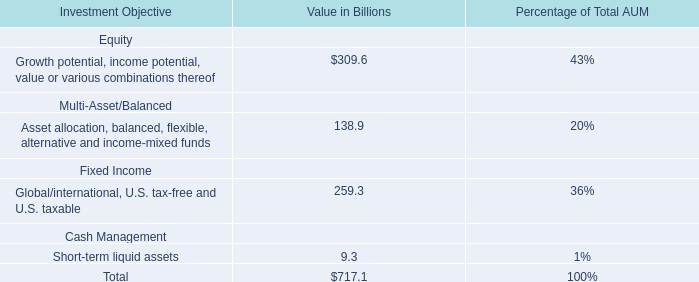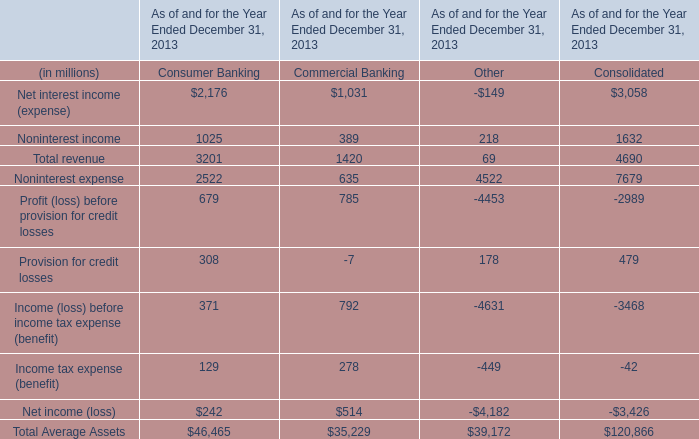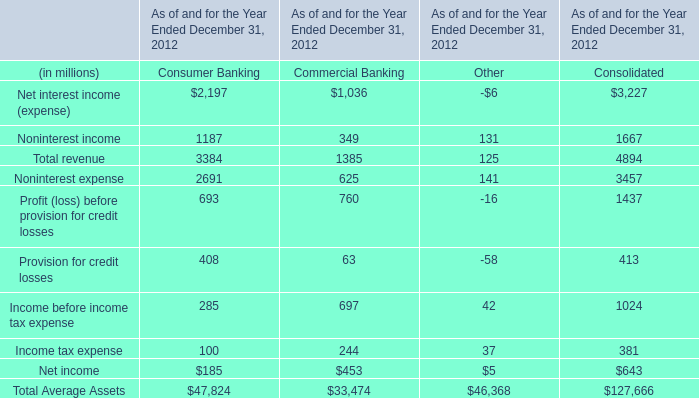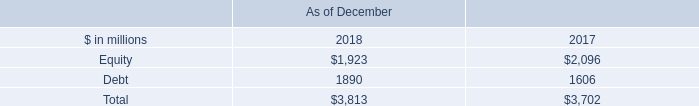What is the sum of the Total revenue in the years where Noninterest income is greater than 0? (in million) 
Computations: (((3384 + 1385) + 125) + 4894)
Answer: 9788.0. 